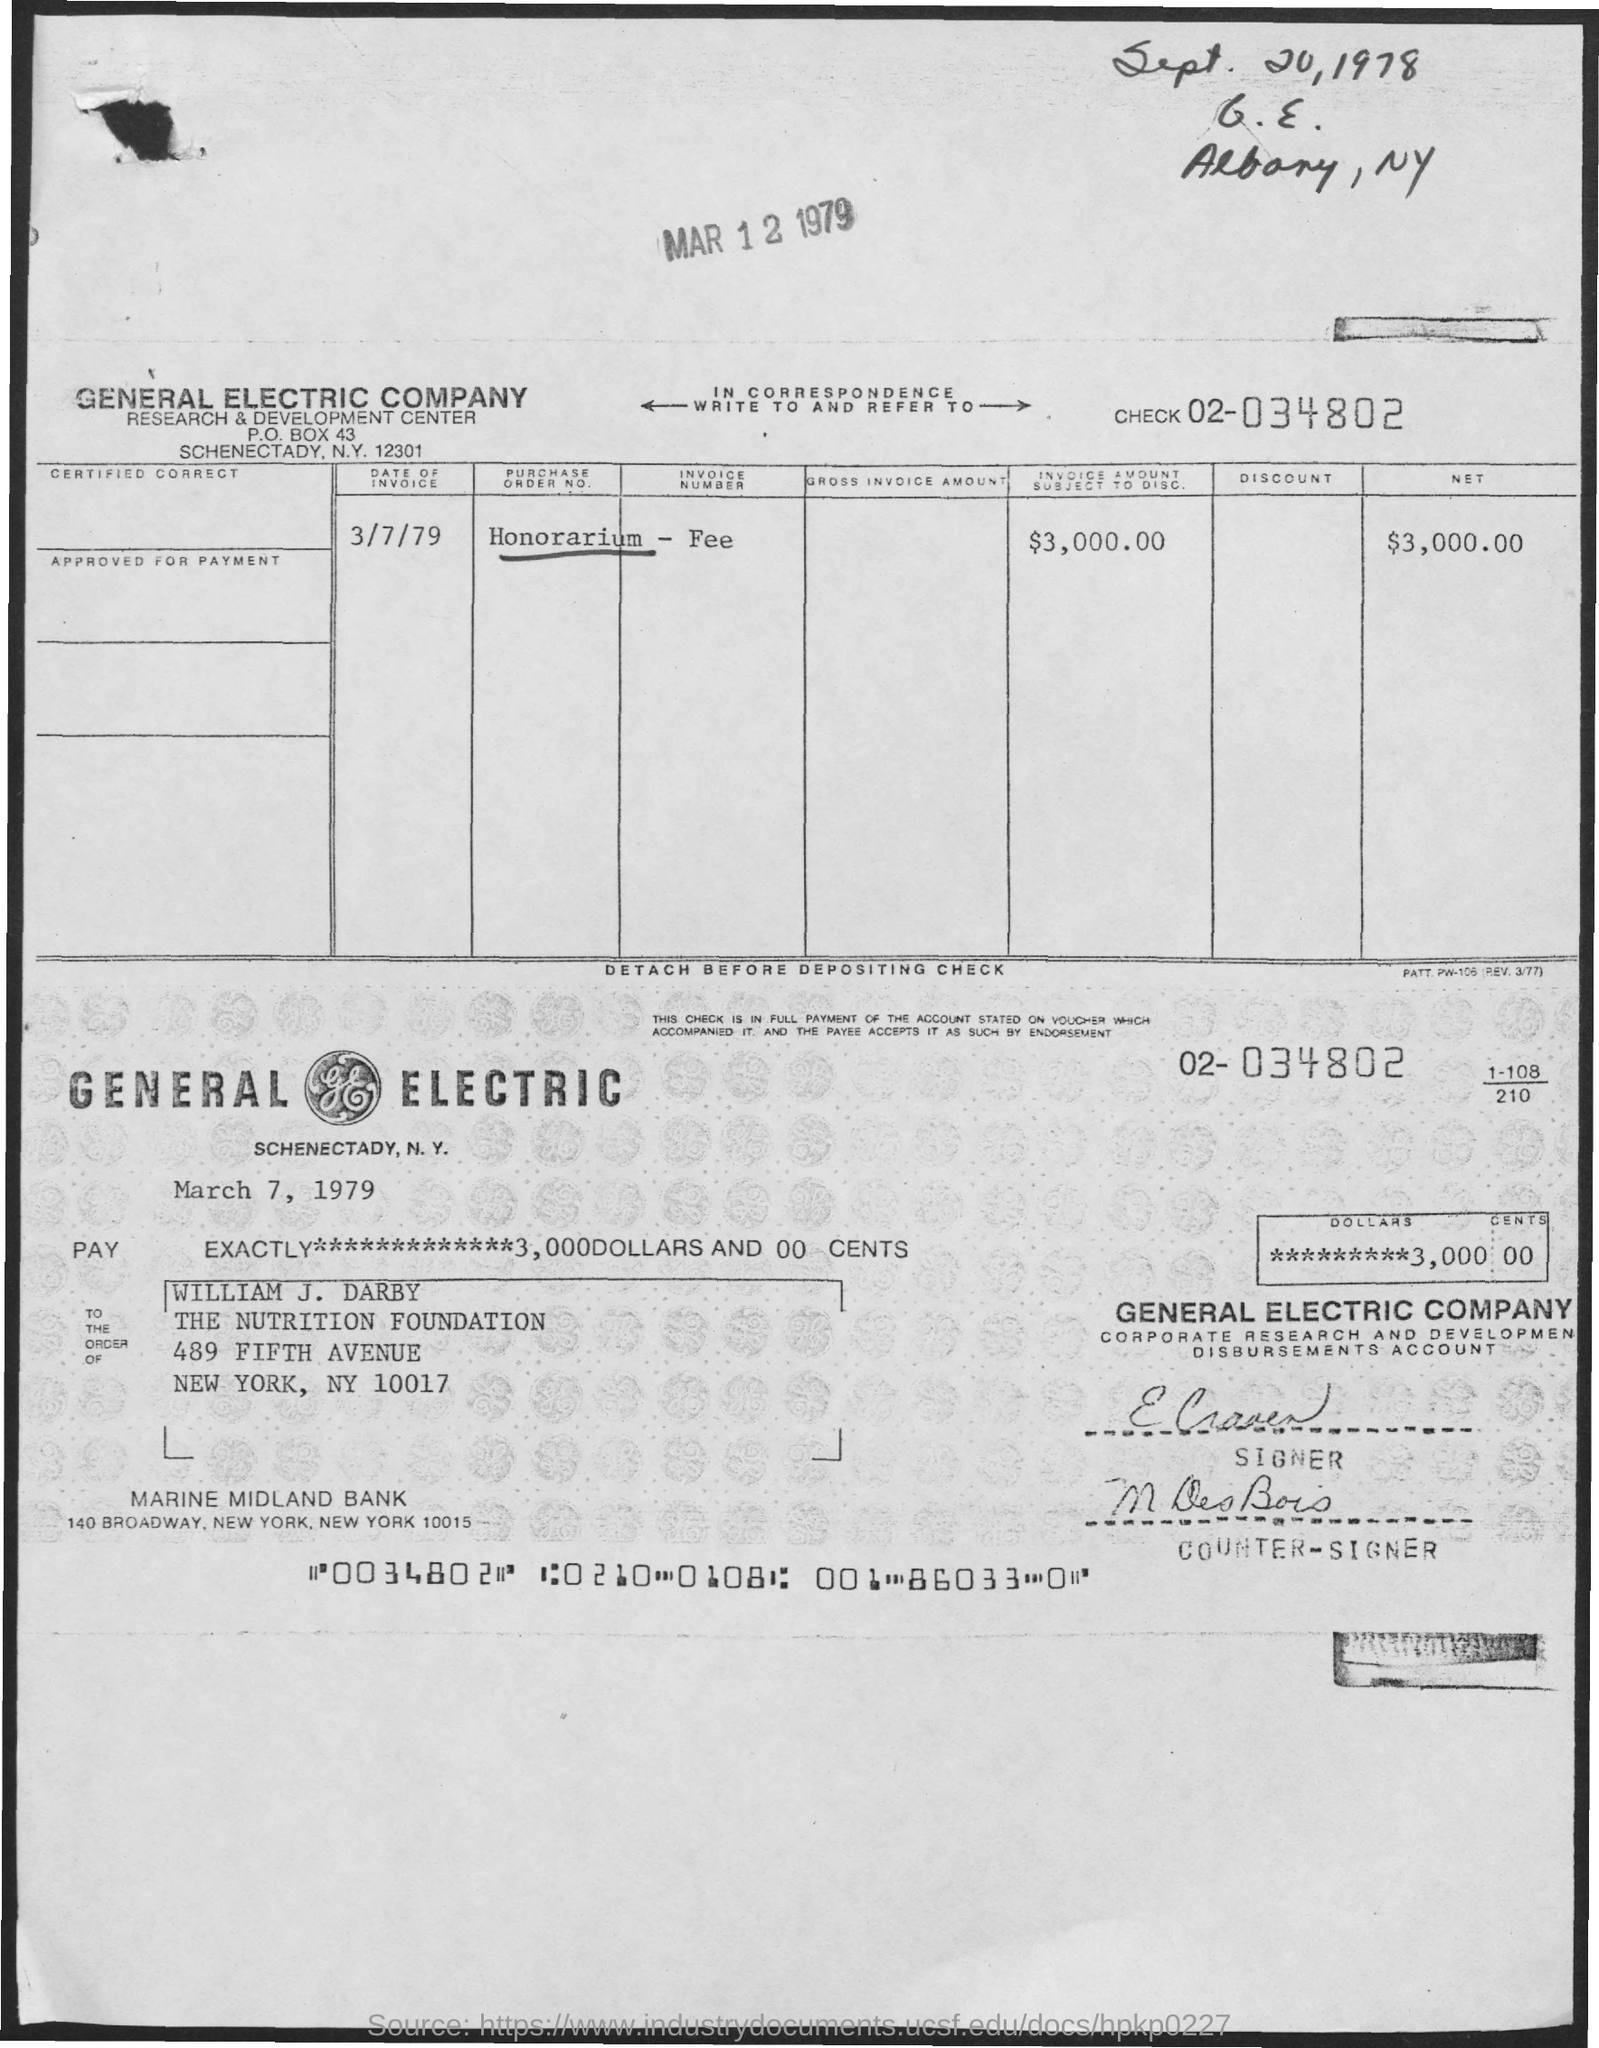What is the date of the Invoice?
Provide a succinct answer. 3/7/79. What is the net amount?
Ensure brevity in your answer.  $3,000.00. 